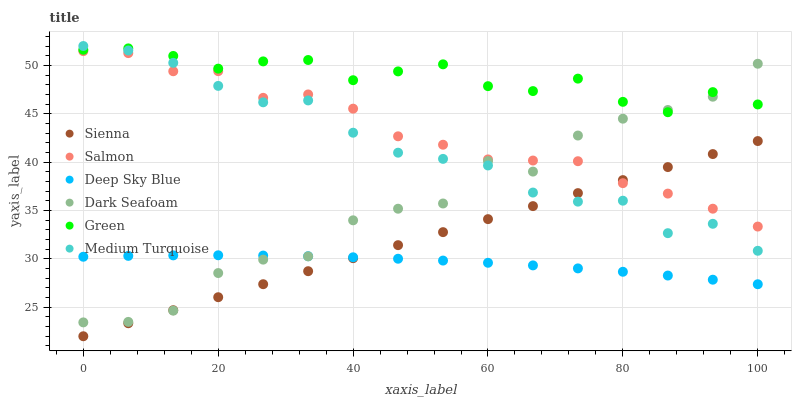Does Deep Sky Blue have the minimum area under the curve?
Answer yes or no. Yes. Does Green have the maximum area under the curve?
Answer yes or no. Yes. Does Salmon have the minimum area under the curve?
Answer yes or no. No. Does Salmon have the maximum area under the curve?
Answer yes or no. No. Is Sienna the smoothest?
Answer yes or no. Yes. Is Dark Seafoam the roughest?
Answer yes or no. Yes. Is Salmon the smoothest?
Answer yes or no. No. Is Salmon the roughest?
Answer yes or no. No. Does Sienna have the lowest value?
Answer yes or no. Yes. Does Salmon have the lowest value?
Answer yes or no. No. Does Medium Turquoise have the highest value?
Answer yes or no. Yes. Does Salmon have the highest value?
Answer yes or no. No. Is Deep Sky Blue less than Medium Turquoise?
Answer yes or no. Yes. Is Medium Turquoise greater than Deep Sky Blue?
Answer yes or no. Yes. Does Deep Sky Blue intersect Sienna?
Answer yes or no. Yes. Is Deep Sky Blue less than Sienna?
Answer yes or no. No. Is Deep Sky Blue greater than Sienna?
Answer yes or no. No. Does Deep Sky Blue intersect Medium Turquoise?
Answer yes or no. No. 